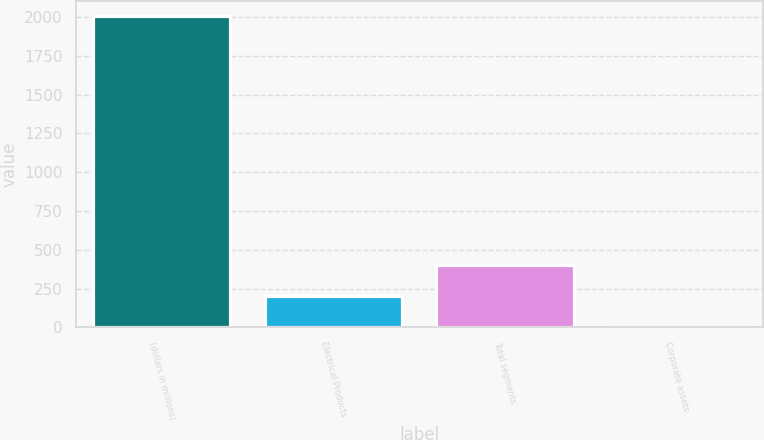Convert chart to OTSL. <chart><loc_0><loc_0><loc_500><loc_500><bar_chart><fcel>(dollars in millions)<fcel>Electrical Products<fcel>Total segments<fcel>Corporate assets<nl><fcel>2005<fcel>201.04<fcel>401.48<fcel>0.6<nl></chart> 